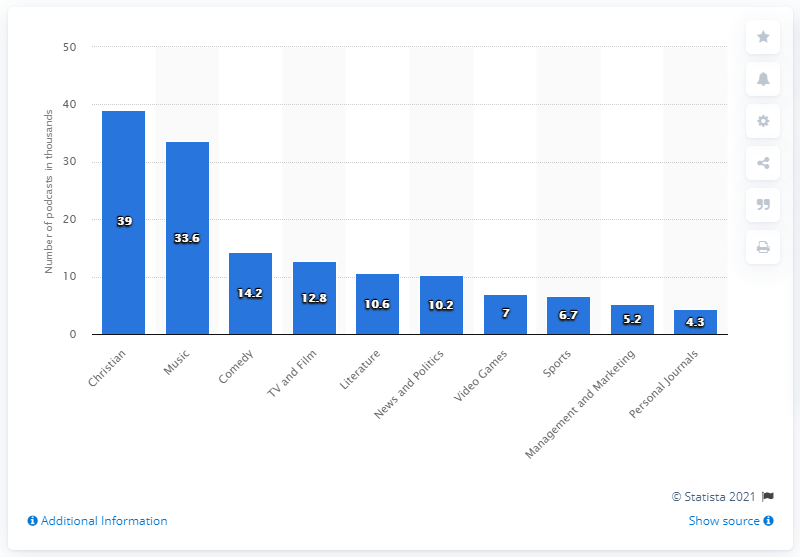Give some essential details in this illustration. There were 14.2 active podcasts in 2015. 